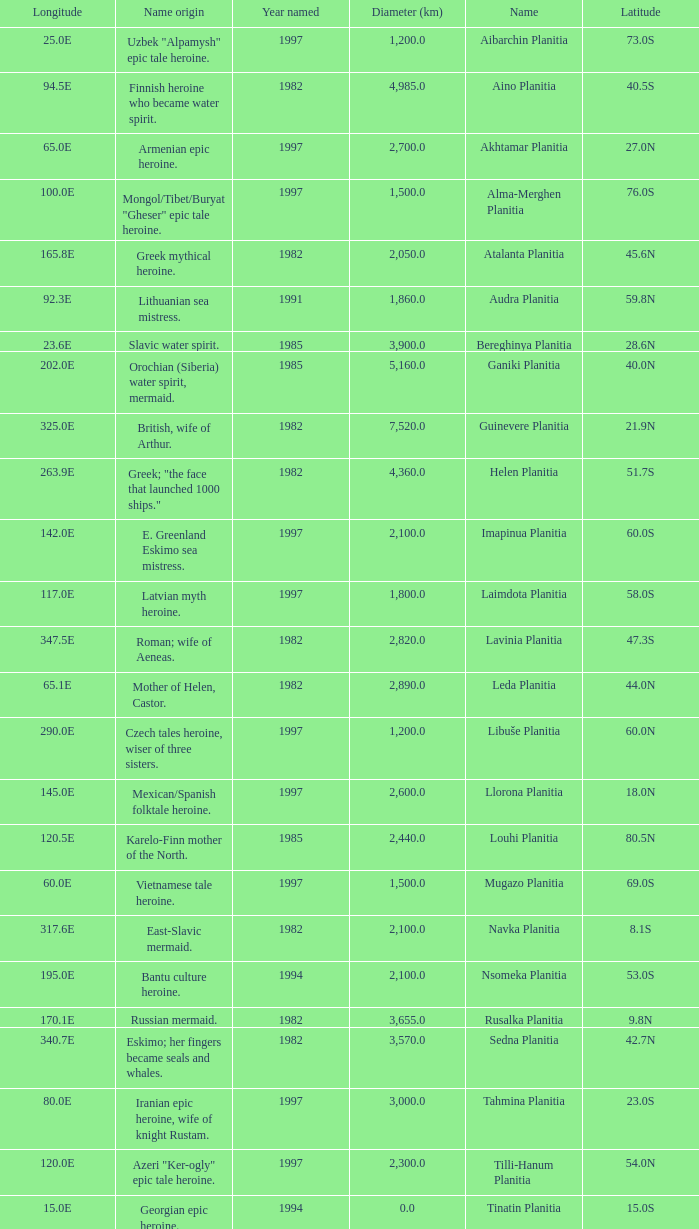What is the diameter (km) of longitude 170.1e 3655.0. 